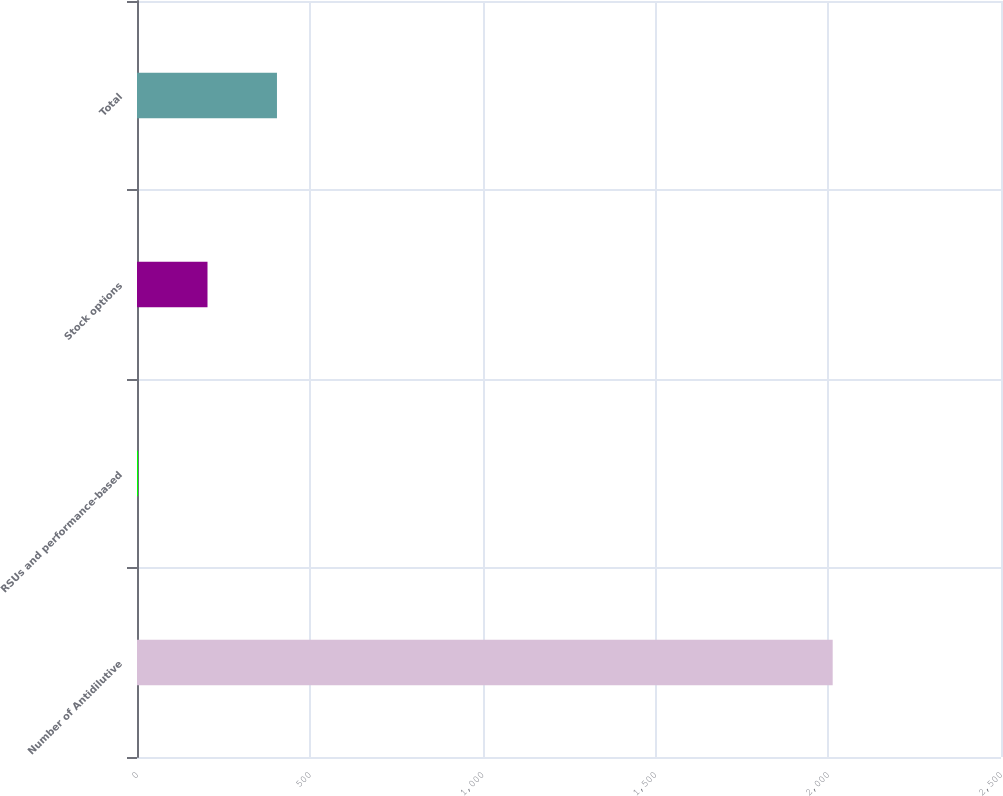Convert chart. <chart><loc_0><loc_0><loc_500><loc_500><bar_chart><fcel>Number of Antidilutive<fcel>RSUs and performance-based<fcel>Stock options<fcel>Total<nl><fcel>2013<fcel>3<fcel>204<fcel>405<nl></chart> 